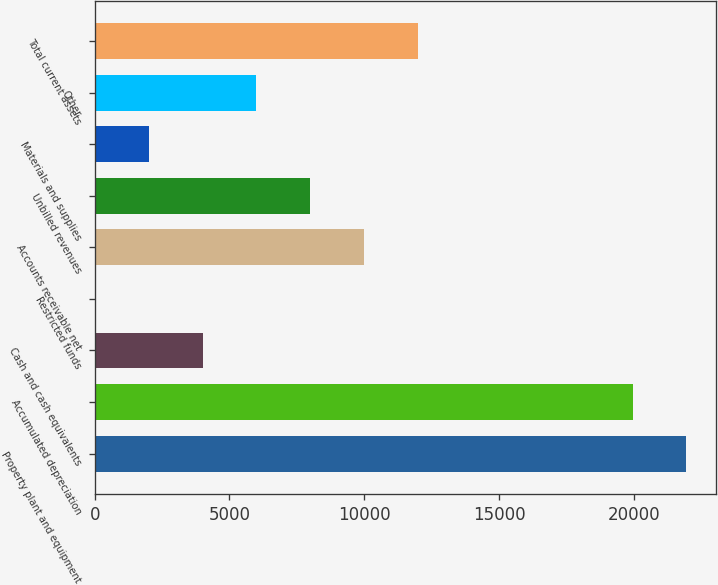<chart> <loc_0><loc_0><loc_500><loc_500><bar_chart><fcel>Property plant and equipment<fcel>Accumulated depreciation<fcel>Cash and cash equivalents<fcel>Restricted funds<fcel>Accounts receivable net<fcel>Unbilled revenues<fcel>Materials and supplies<fcel>Other<fcel>Total current assets<nl><fcel>21947.4<fcel>19954<fcel>4006.8<fcel>20<fcel>9987<fcel>7993.6<fcel>2013.4<fcel>6000.2<fcel>11980.4<nl></chart> 